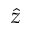<formula> <loc_0><loc_0><loc_500><loc_500>\hat { z }</formula> 